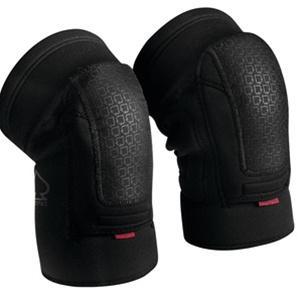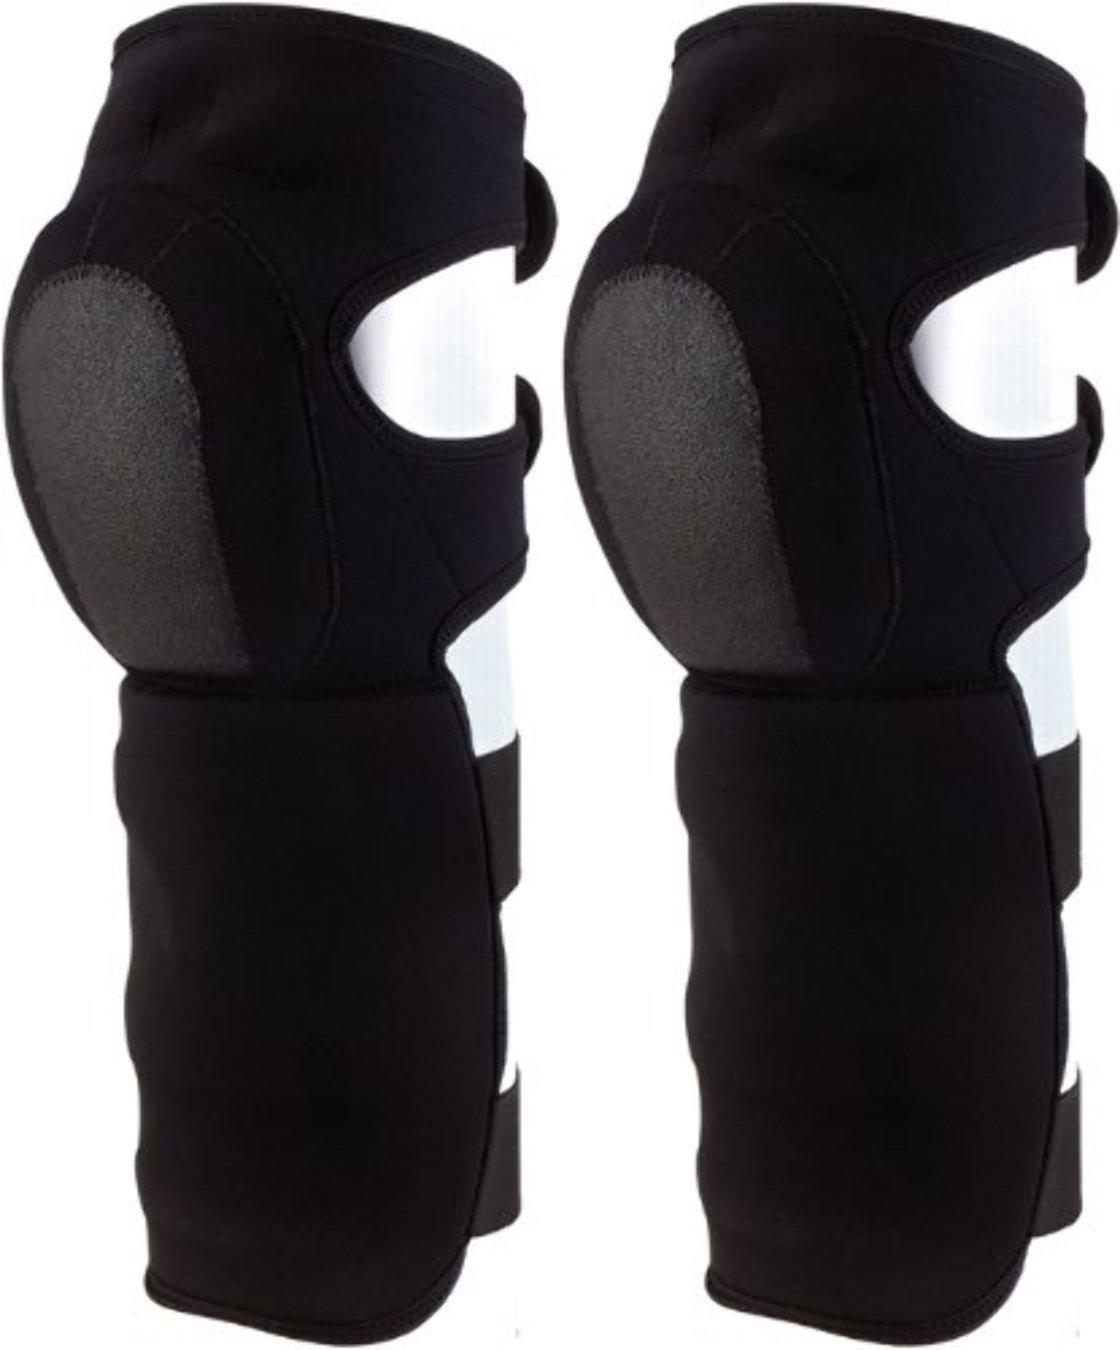The first image is the image on the left, the second image is the image on the right. Assess this claim about the two images: "The image on the right contains both knee and shin guards.". Correct or not? Answer yes or no. Yes. 